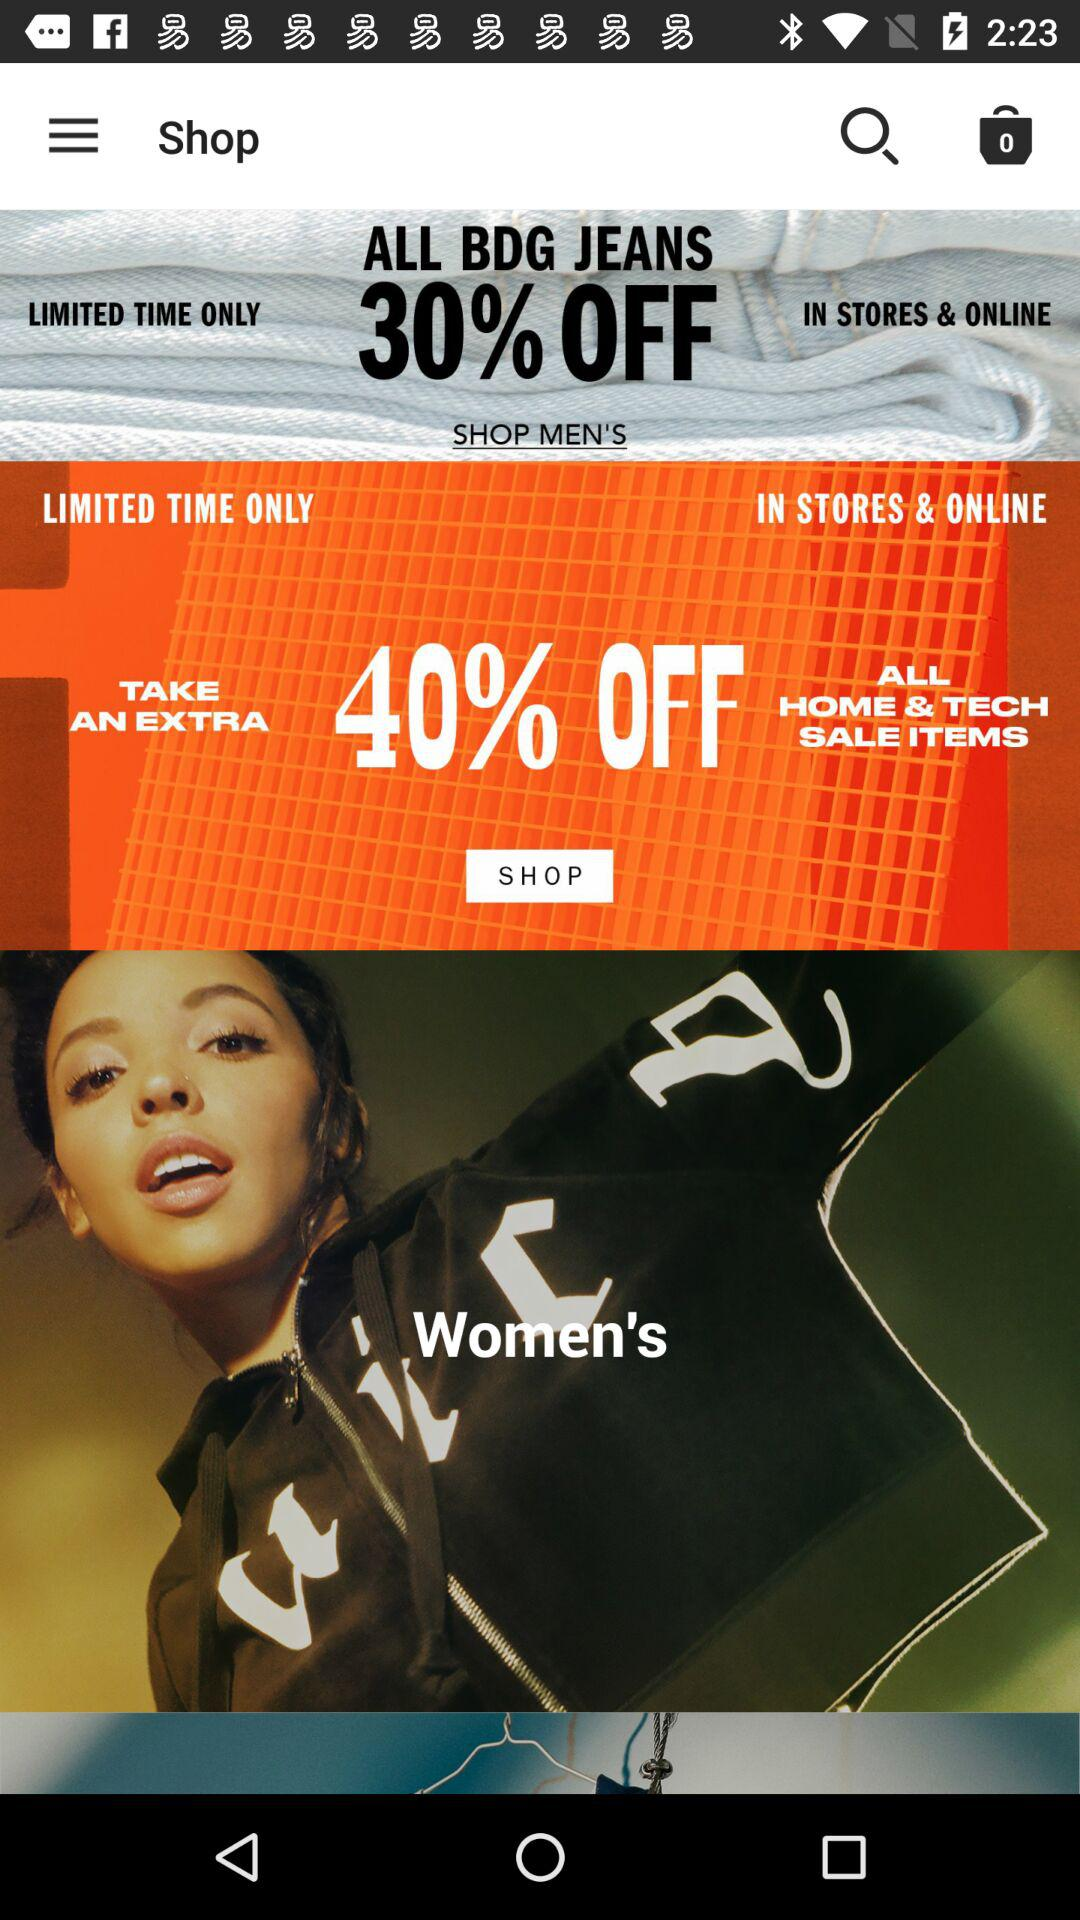How many items are in the bag? There are 0 items. 